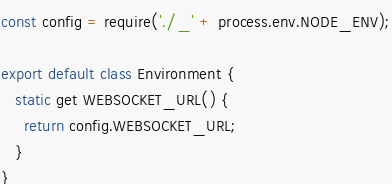<code> <loc_0><loc_0><loc_500><loc_500><_JavaScript_>const config = require('./_' + process.env.NODE_ENV);

export default class Environment {
   static get WEBSOCKET_URL() {
     return config.WEBSOCKET_URL;
   }
}</code> 